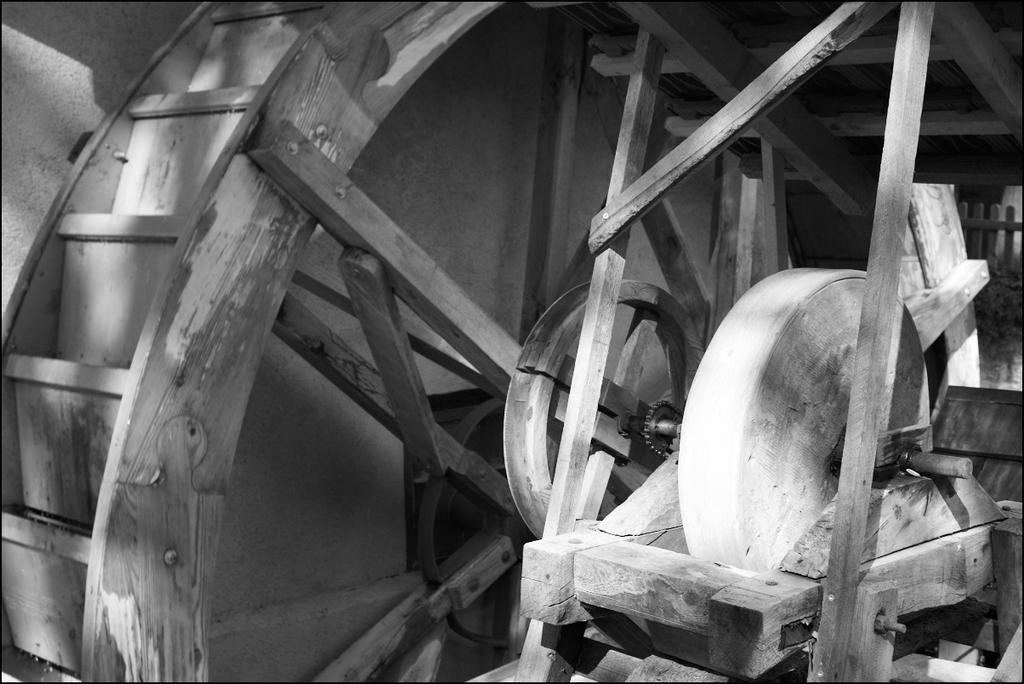Describe this image in one or two sentences. In this image we can see a wooden object. We can see the wall in the image. There is a fence at the right side of the image. 